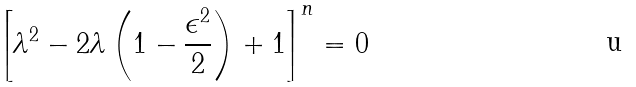<formula> <loc_0><loc_0><loc_500><loc_500>\left [ \lambda ^ { 2 } - 2 \lambda \left ( 1 - \frac { \epsilon ^ { 2 } } { 2 } \right ) + 1 \right ] ^ { n } = 0</formula> 